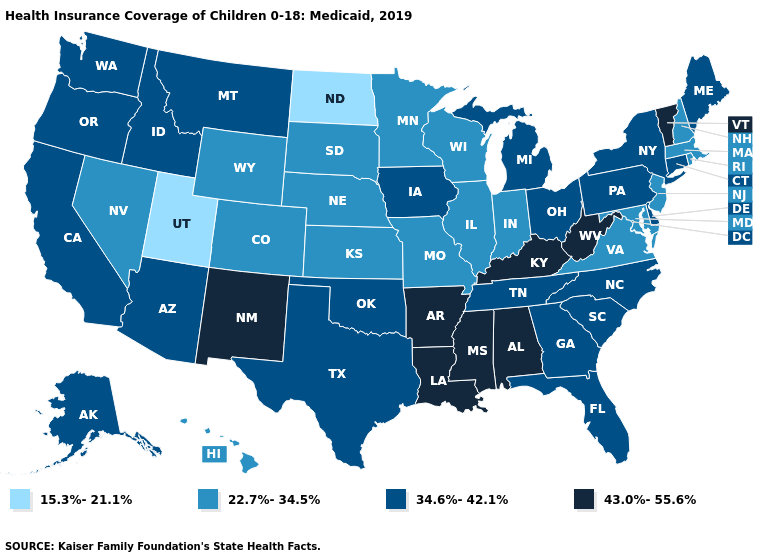Among the states that border New Mexico , does Utah have the highest value?
Give a very brief answer. No. Name the states that have a value in the range 22.7%-34.5%?
Short answer required. Colorado, Hawaii, Illinois, Indiana, Kansas, Maryland, Massachusetts, Minnesota, Missouri, Nebraska, Nevada, New Hampshire, New Jersey, Rhode Island, South Dakota, Virginia, Wisconsin, Wyoming. Does the map have missing data?
Answer briefly. No. What is the lowest value in the Northeast?
Write a very short answer. 22.7%-34.5%. Among the states that border Florida , does Alabama have the lowest value?
Write a very short answer. No. Is the legend a continuous bar?
Write a very short answer. No. What is the highest value in the MidWest ?
Short answer required. 34.6%-42.1%. What is the value of Arkansas?
Write a very short answer. 43.0%-55.6%. What is the lowest value in the MidWest?
Answer briefly. 15.3%-21.1%. Name the states that have a value in the range 15.3%-21.1%?
Quick response, please. North Dakota, Utah. Name the states that have a value in the range 15.3%-21.1%?
Keep it brief. North Dakota, Utah. Name the states that have a value in the range 15.3%-21.1%?
Concise answer only. North Dakota, Utah. Which states have the lowest value in the Northeast?
Be succinct. Massachusetts, New Hampshire, New Jersey, Rhode Island. Name the states that have a value in the range 43.0%-55.6%?
Keep it brief. Alabama, Arkansas, Kentucky, Louisiana, Mississippi, New Mexico, Vermont, West Virginia. Name the states that have a value in the range 15.3%-21.1%?
Quick response, please. North Dakota, Utah. 